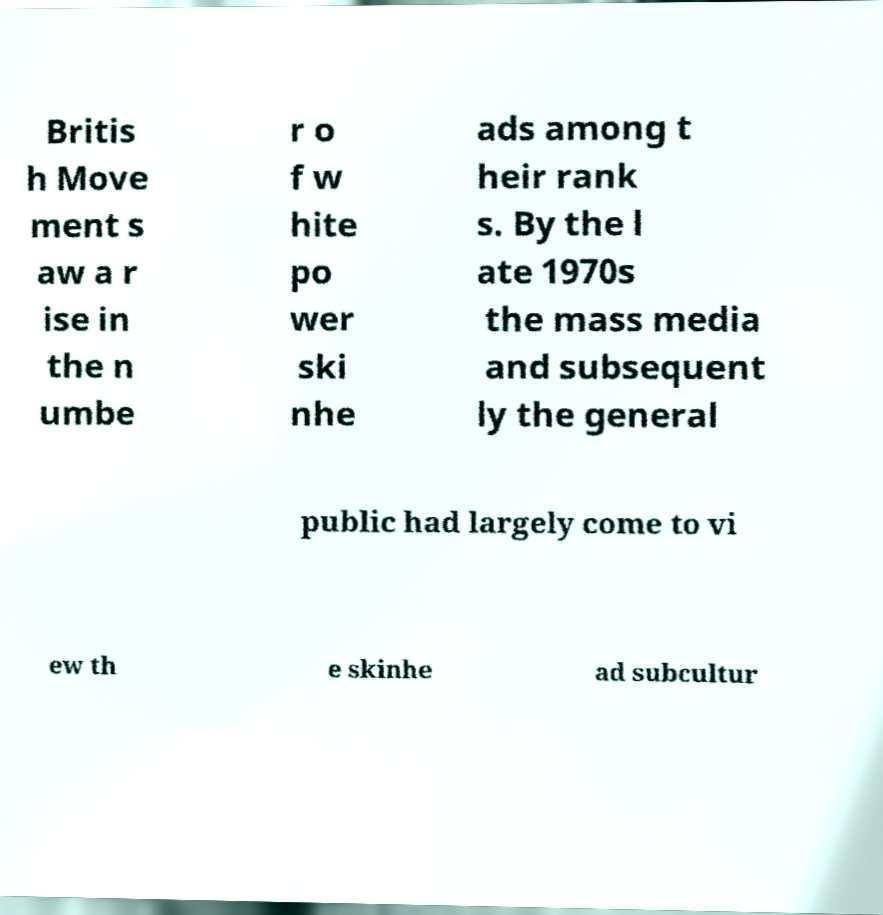Can you accurately transcribe the text from the provided image for me? Britis h Move ment s aw a r ise in the n umbe r o f w hite po wer ski nhe ads among t heir rank s. By the l ate 1970s the mass media and subsequent ly the general public had largely come to vi ew th e skinhe ad subcultur 